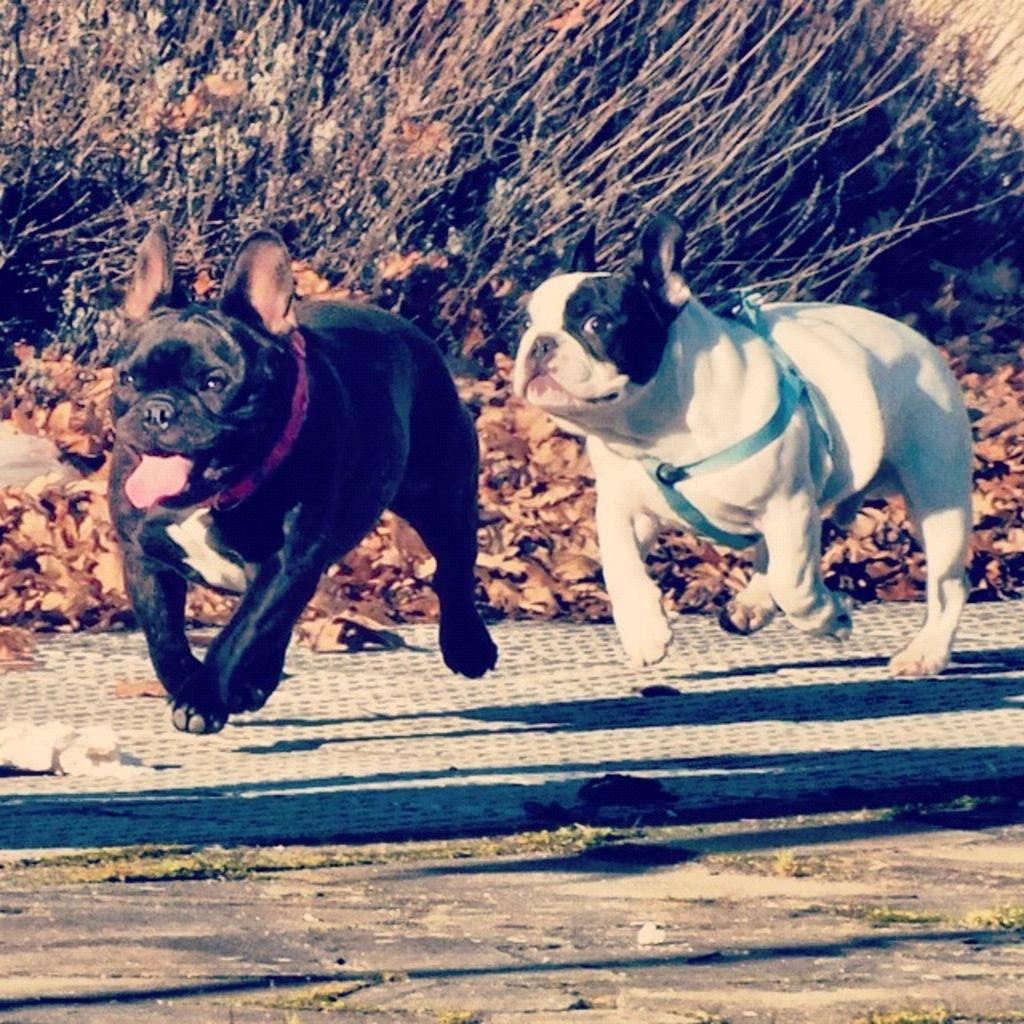How many dogs can be seen in the image? There are two dogs in the image. What are the dogs doing in the image? The dogs are running. What is at the bottom of the image? There is a road at the bottom of the image. What can be seen in the background of the image? Dried leaves and plants are visible in the background of the image. How many birds are flying with wings spread wide in the image? There are no birds present in the image. What type of hole can be seen in the image? There is no hole visible in the image. 